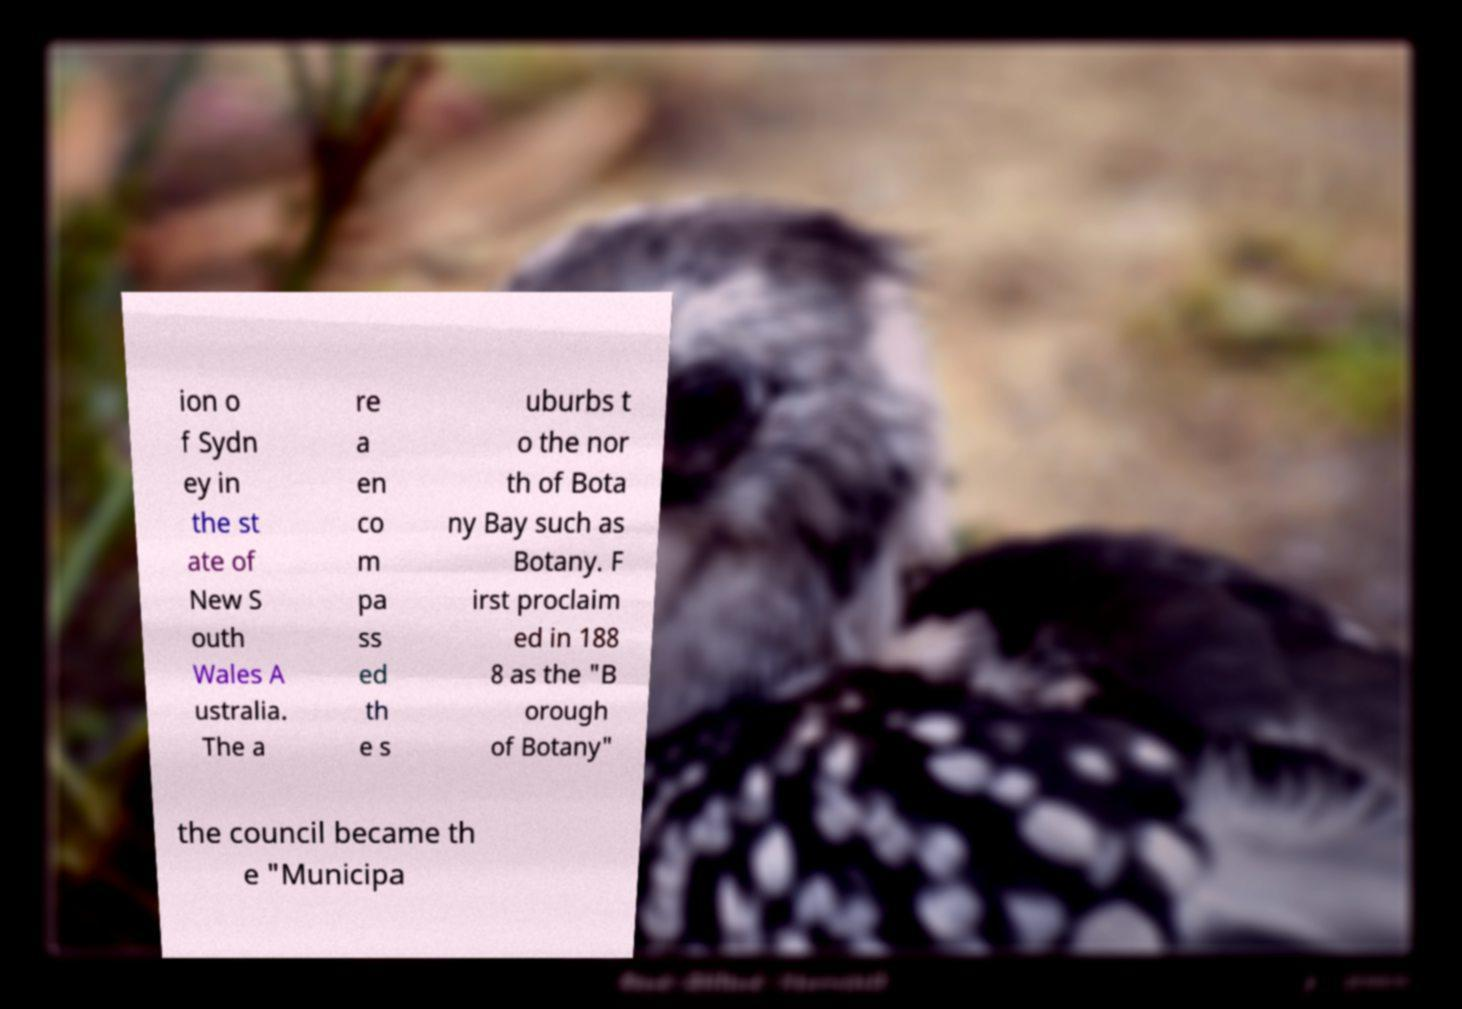Please identify and transcribe the text found in this image. ion o f Sydn ey in the st ate of New S outh Wales A ustralia. The a re a en co m pa ss ed th e s uburbs t o the nor th of Bota ny Bay such as Botany. F irst proclaim ed in 188 8 as the "B orough of Botany" the council became th e "Municipa 